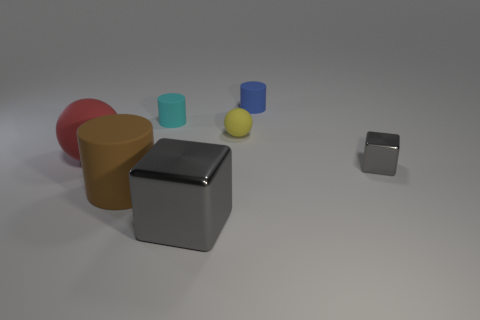Subtract all yellow cubes. Subtract all blue cylinders. How many cubes are left? 2 Add 3 big matte cylinders. How many objects exist? 10 Subtract all balls. How many objects are left? 5 Add 6 small balls. How many small balls are left? 7 Add 6 big metal cylinders. How many big metal cylinders exist? 6 Subtract 0 cyan balls. How many objects are left? 7 Subtract all gray metallic things. Subtract all brown matte things. How many objects are left? 4 